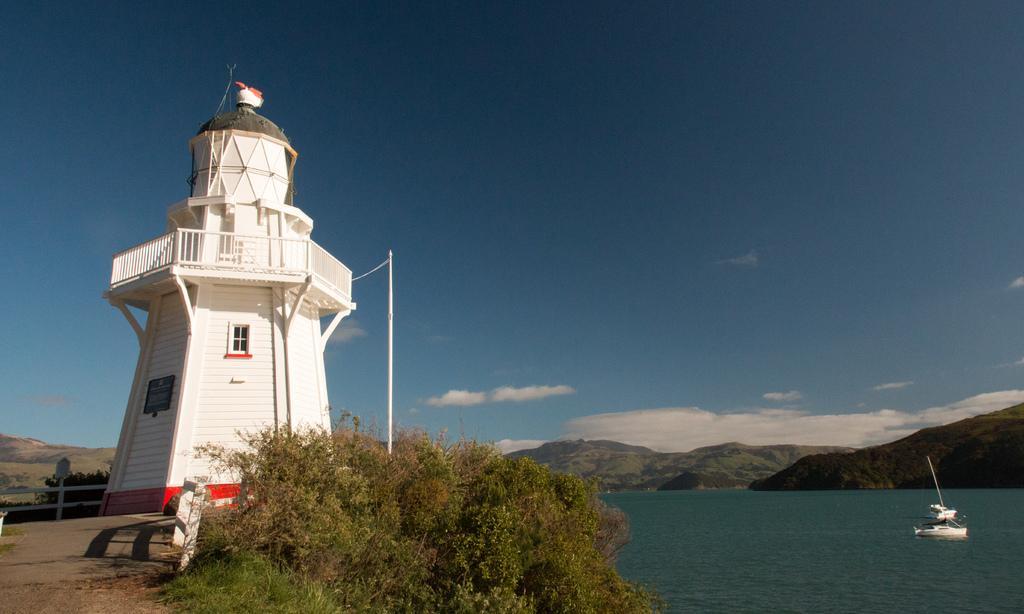In one or two sentences, can you explain what this image depicts? In this image we can see a lighthouse, few trees, ramming, boat on the water, mountains and the sky with clouds in the background. 